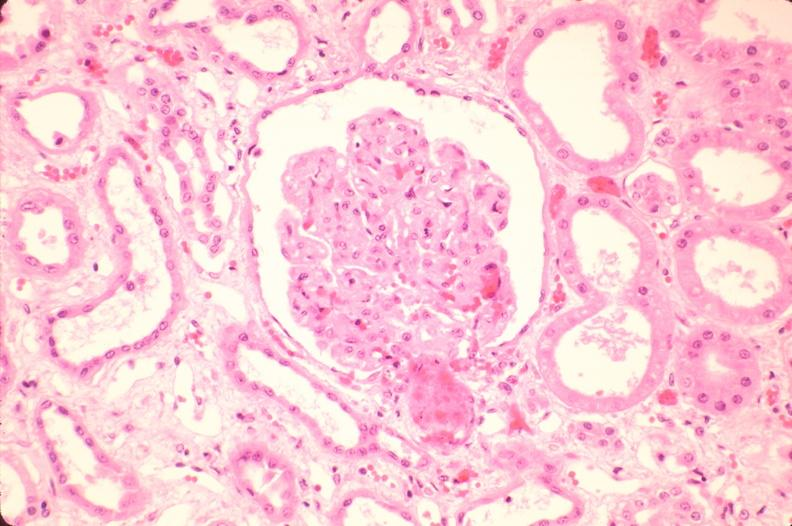what does this image show?
Answer the question using a single word or phrase. Kidney 